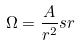Convert formula to latex. <formula><loc_0><loc_0><loc_500><loc_500>\Omega = \frac { A } { r ^ { 2 } } s r</formula> 